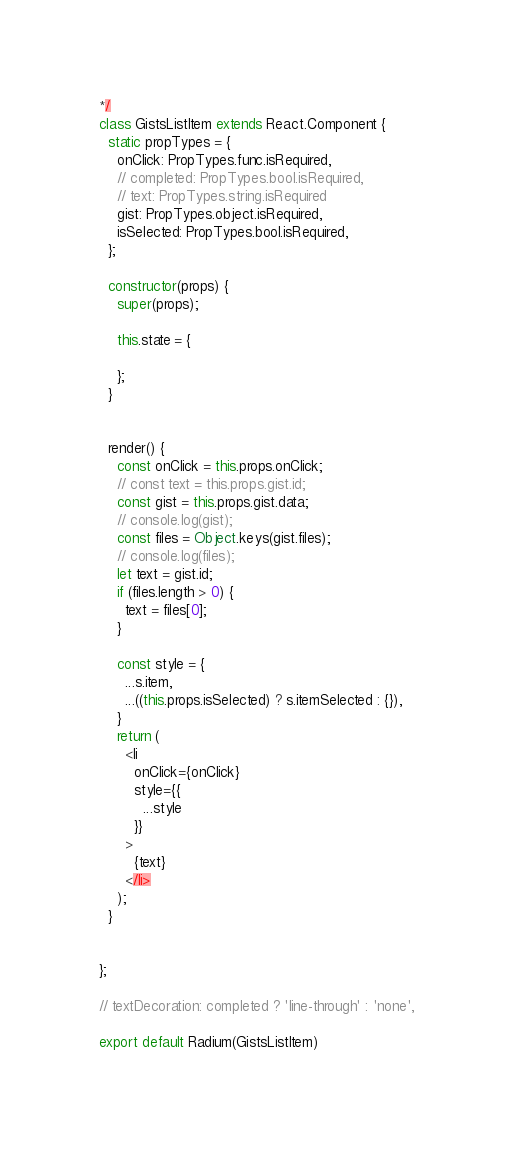<code> <loc_0><loc_0><loc_500><loc_500><_JavaScript_>*/
class GistsListItem extends React.Component {
  static propTypes = {
    onClick: PropTypes.func.isRequired,
    // completed: PropTypes.bool.isRequired,
    // text: PropTypes.string.isRequired
    gist: PropTypes.object.isRequired,
    isSelected: PropTypes.bool.isRequired,
  };

  constructor(props) {
    super(props);

    this.state = {

    };
  }


  render() {
    const onClick = this.props.onClick;
    // const text = this.props.gist.id;
    const gist = this.props.gist.data;
    // console.log(gist);
    const files = Object.keys(gist.files);
    // console.log(files);
    let text = gist.id;
    if (files.length > 0) {
      text = files[0];
    }

    const style = {
      ...s.item,
      ...((this.props.isSelected) ? s.itemSelected : {}),
    }
    return (
      <li
        onClick={onClick}
        style={{
          ...style
        }}
      >
        {text}
      </li>
    );
  }


};

// textDecoration: completed ? 'line-through' : 'none',

export default Radium(GistsListItem)
</code> 